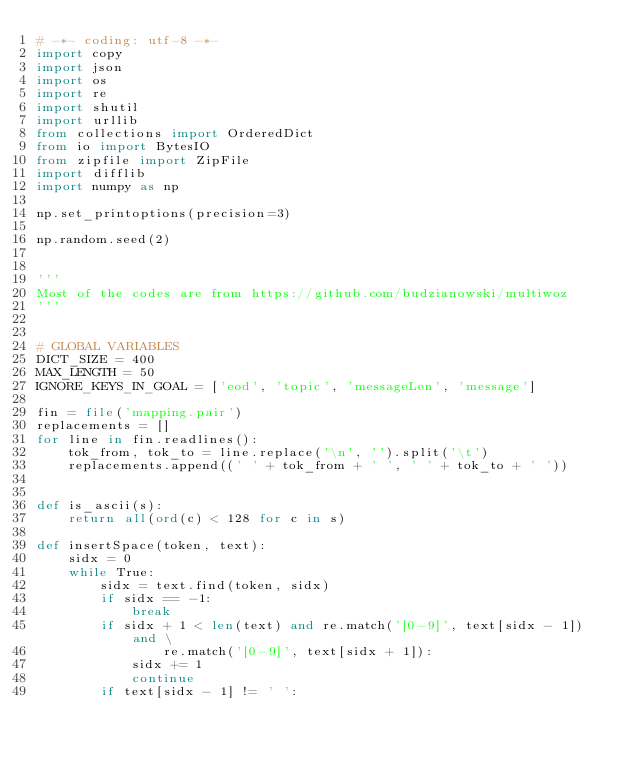<code> <loc_0><loc_0><loc_500><loc_500><_Python_># -*- coding: utf-8 -*-
import copy
import json
import os
import re
import shutil
import urllib
from collections import OrderedDict
from io import BytesIO
from zipfile import ZipFile
import difflib
import numpy as np

np.set_printoptions(precision=3)

np.random.seed(2)


'''
Most of the codes are from https://github.com/budzianowski/multiwoz
'''


# GLOBAL VARIABLES
DICT_SIZE = 400
MAX_LENGTH = 50
IGNORE_KEYS_IN_GOAL = ['eod', 'topic', 'messageLen', 'message']

fin = file('mapping.pair')
replacements = []
for line in fin.readlines():
    tok_from, tok_to = line.replace('\n', '').split('\t')
    replacements.append((' ' + tok_from + ' ', ' ' + tok_to + ' '))


def is_ascii(s):
    return all(ord(c) < 128 for c in s)

def insertSpace(token, text):
    sidx = 0
    while True:
        sidx = text.find(token, sidx)
        if sidx == -1:
            break
        if sidx + 1 < len(text) and re.match('[0-9]', text[sidx - 1]) and \
                re.match('[0-9]', text[sidx + 1]):
            sidx += 1
            continue
        if text[sidx - 1] != ' ':</code> 